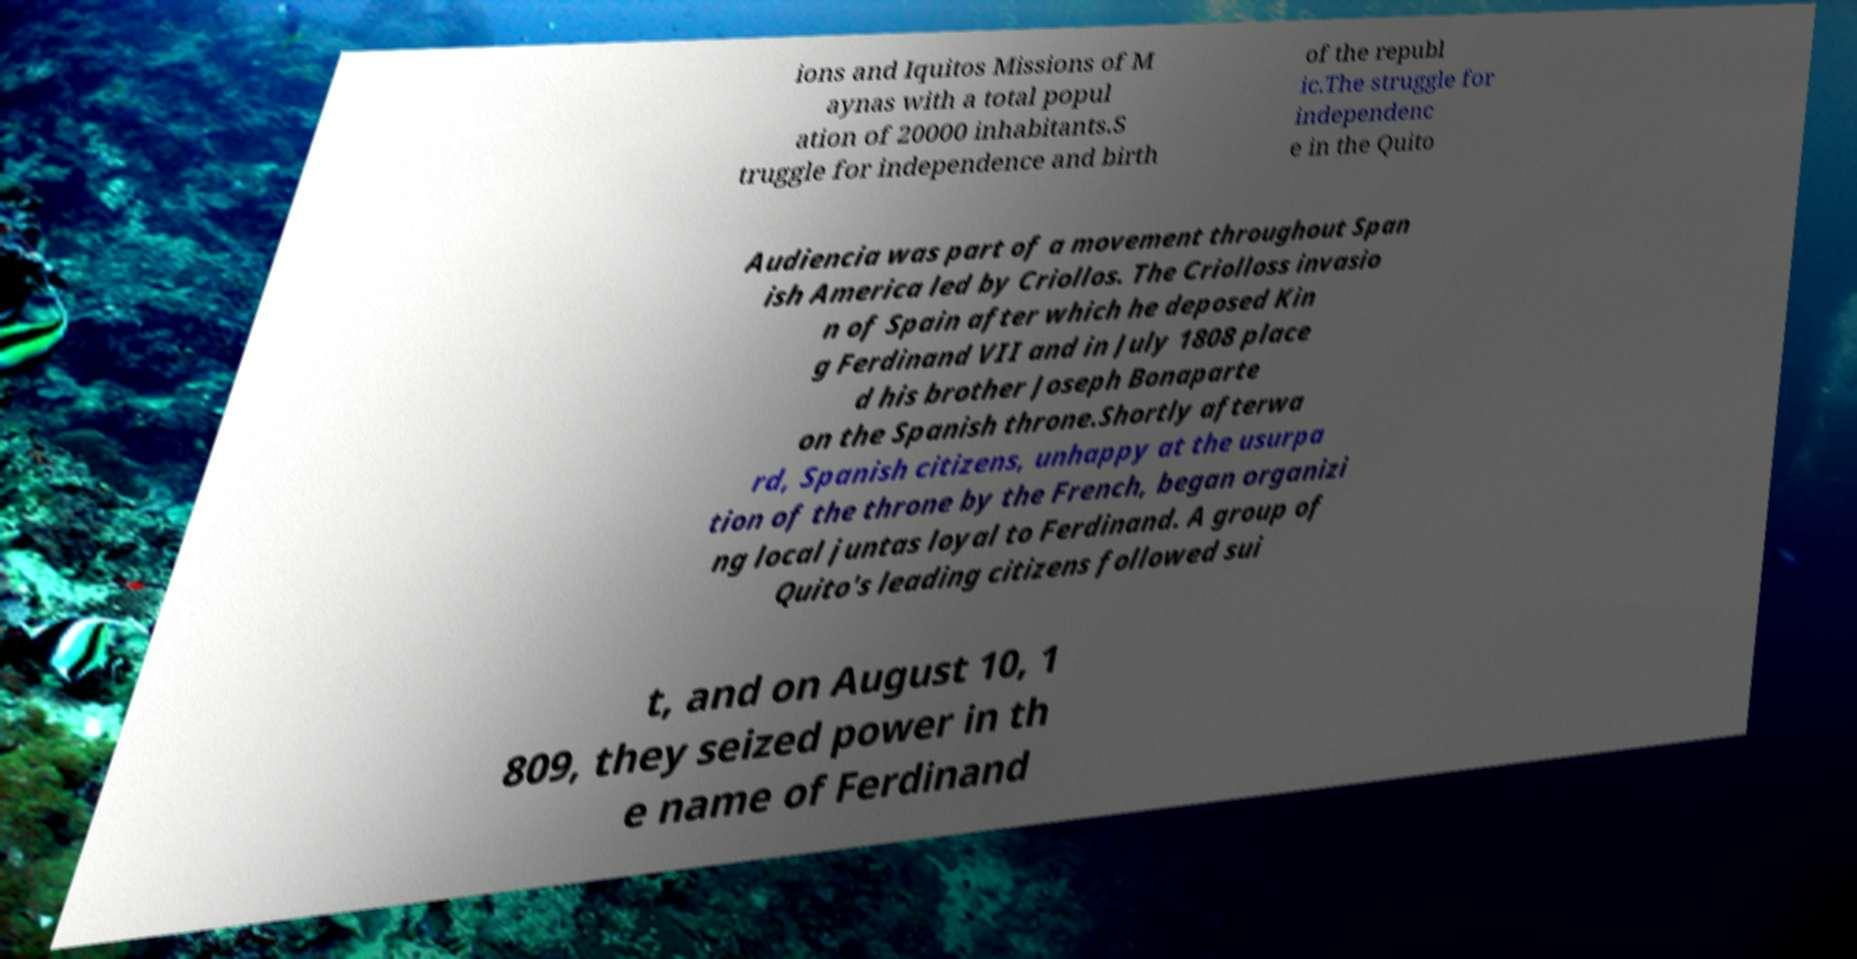Can you accurately transcribe the text from the provided image for me? ions and Iquitos Missions of M aynas with a total popul ation of 20000 inhabitants.S truggle for independence and birth of the republ ic.The struggle for independenc e in the Quito Audiencia was part of a movement throughout Span ish America led by Criollos. The Criolloss invasio n of Spain after which he deposed Kin g Ferdinand VII and in July 1808 place d his brother Joseph Bonaparte on the Spanish throne.Shortly afterwa rd, Spanish citizens, unhappy at the usurpa tion of the throne by the French, began organizi ng local juntas loyal to Ferdinand. A group of Quito's leading citizens followed sui t, and on August 10, 1 809, they seized power in th e name of Ferdinand 